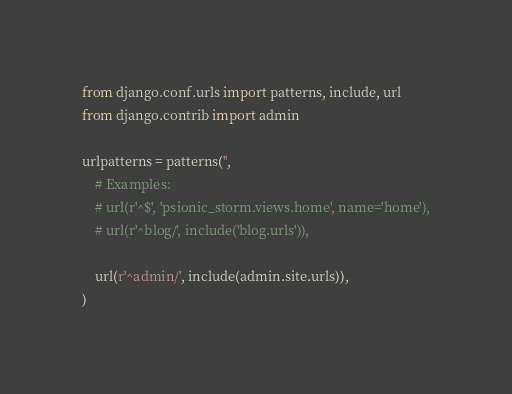Convert code to text. <code><loc_0><loc_0><loc_500><loc_500><_Python_>from django.conf.urls import patterns, include, url
from django.contrib import admin

urlpatterns = patterns('',
    # Examples:
    # url(r'^$', 'psionic_storm.views.home', name='home'),
    # url(r'^blog/', include('blog.urls')),

    url(r'^admin/', include(admin.site.urls)),
)
</code> 